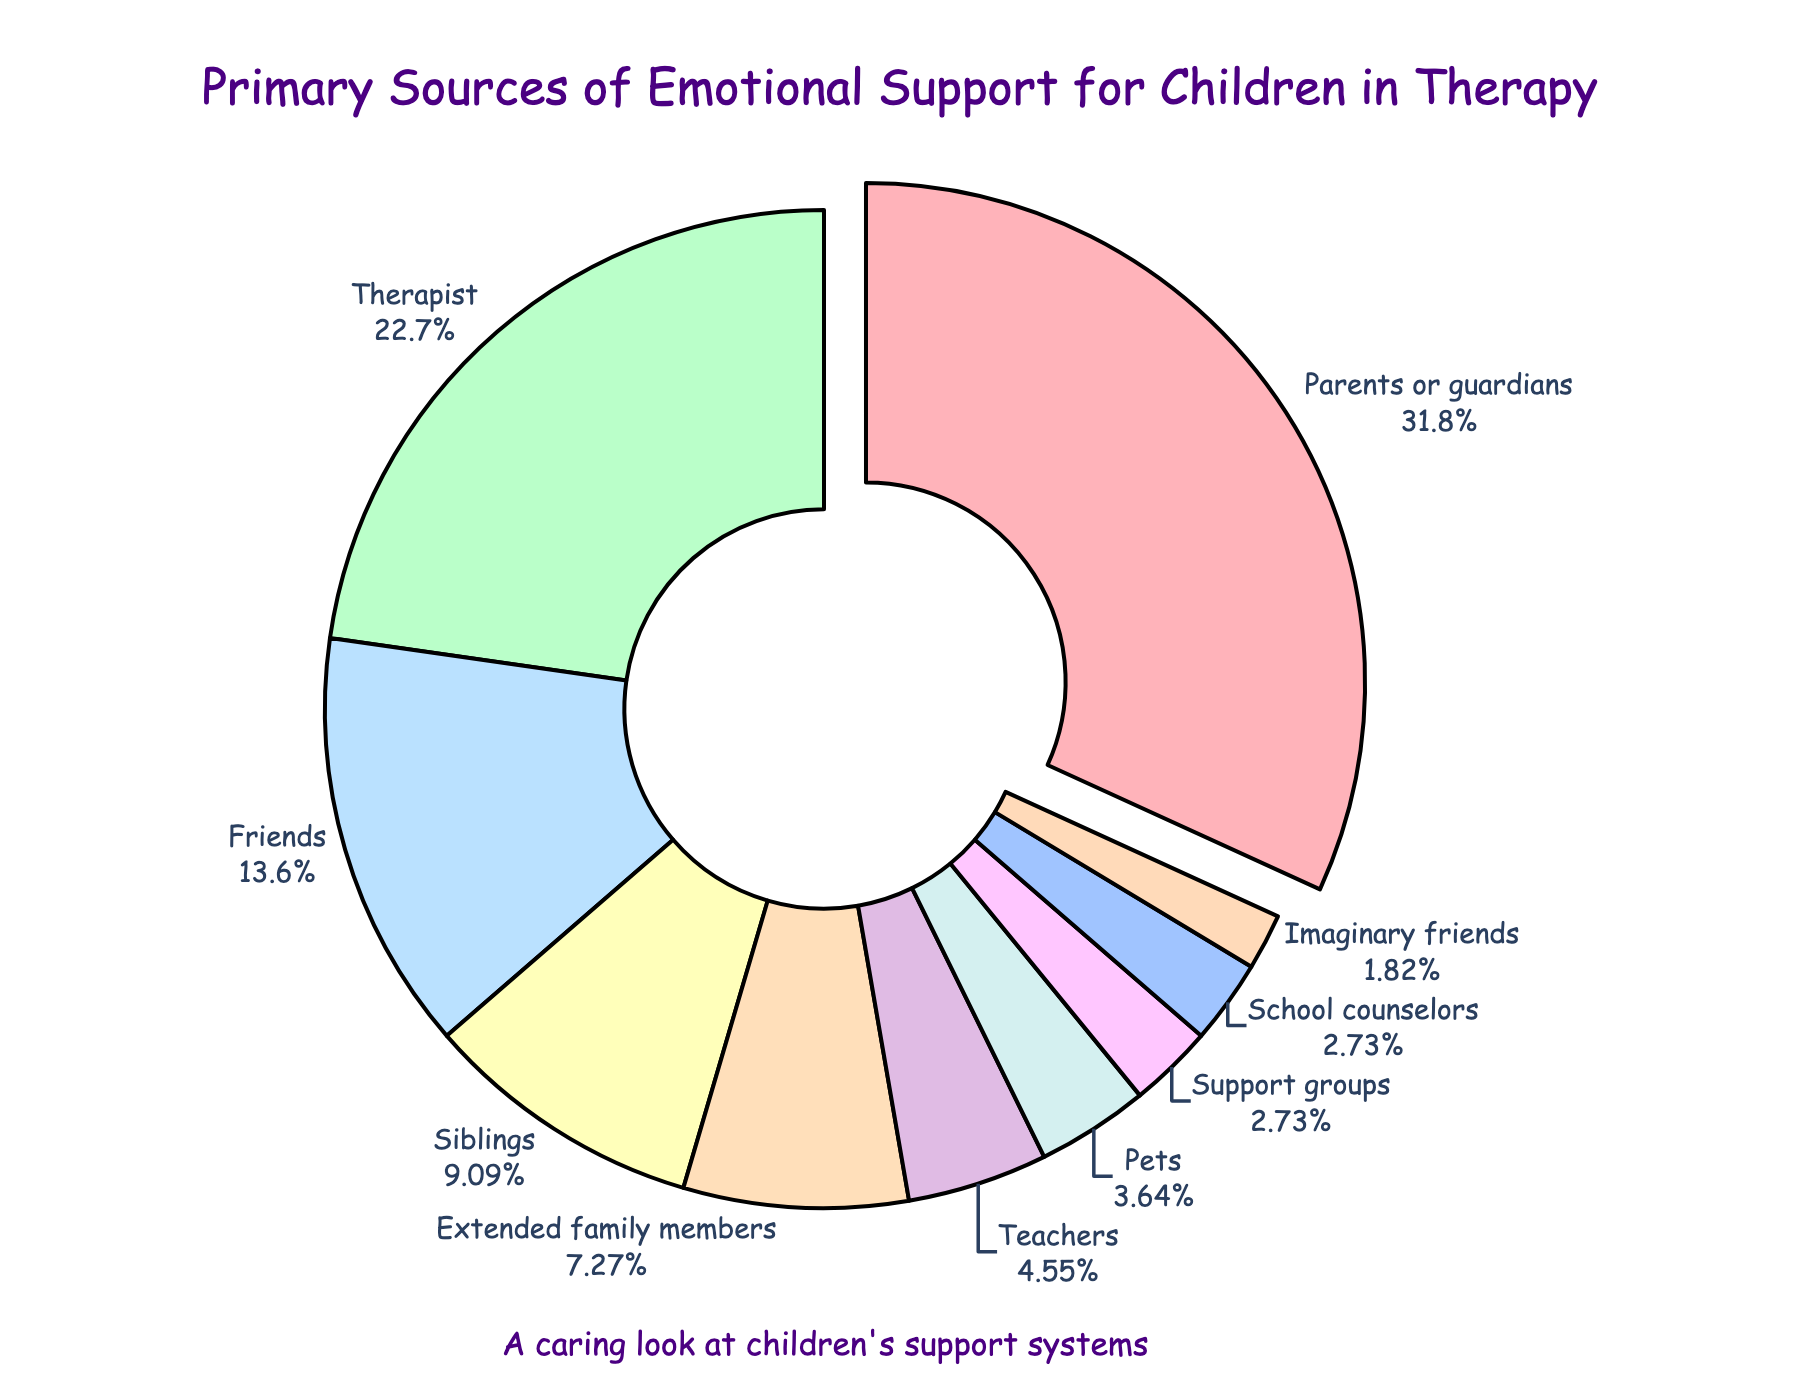What's the primary source of emotional support for children in therapy? The largest segment of the pie chart is prominently indicated by being pulled out slightly from the rest and is labeled "Parents or guardians," with a percentage of 35%.
Answer: Parents or guardians Which source provides more support: friends or siblings? The pie chart shows the percentage for friends as 15% and for siblings as 10%. Comparing these two values, 15% is greater than 10%.
Answer: Friends What percentage of children's emotional support comes from non-family members? Non-family members include therapist (25%), friends (15%), teachers (5%), support groups (3%), school counselors (3%), and pets (4%). Adding these values: 25 + 15 + 5 + 3 + 3 + 4 = 55%.
Answer: 55% How much more support do parents or guardians provide compared to pets? Parents or guardians provide 35% support, while pets provide 4%. The difference is calculated by subtracting 4 from 35. So, 35 - 4 = 31%.
Answer: 31% Which group provides the least amount of emotional support for children in therapy? The smallest segment in the pie chart represents imaginary friends, with a percentage of 2%.
Answer: Imaginary friends What is the combined percentage of support provided by extended family members and teachers? According to the pie chart, extended family members provide 8% and teachers provide 5%. Adding these two values: 8 + 5 = 13%.
Answer: 13% Are teachers and school counselors contributing equally to children's emotional support? Referring to the pie chart, teachers contribute 5% while school counselors contribute 3%. These values are not equal.
Answer: No What fraction of the support is provided by siblings, extended family members, and teachers combined? The percentages for siblings, extended family members, and teachers are 10%, 8%, and 5% respectively. Adding these: 10 + 8 + 5 = 23%. The fraction out of 100 (whole pie) is 23/100, which simplifies to approximately 23%.
Answer: 23% How much support do support groups provide compared to pets? Support groups provide 3% whereas pets provide 4% of the support. Comparing these two values, 3% is less than 4%.
Answer: Less Which is the second most common source of emotional support for children in therapy? The second largest segment in the pie chart is labeled "Therapist," with a percentage of 25%.
Answer: Therapist 